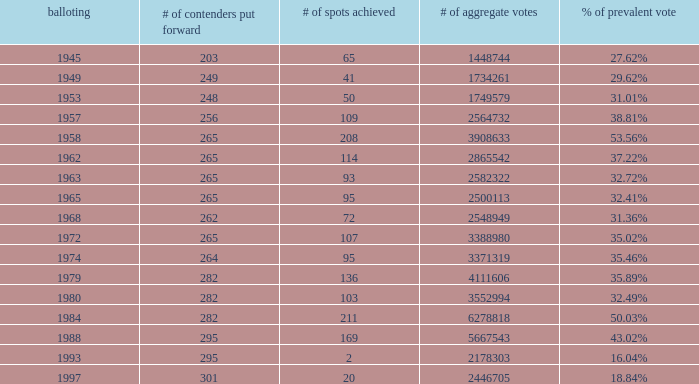What was the number of seats won in the 1974 election? 95.0. 